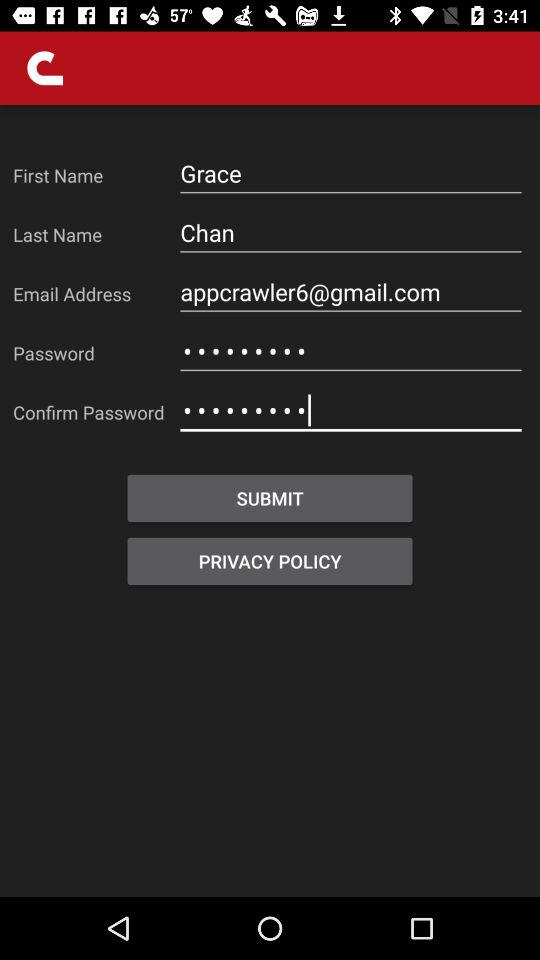What is the last name? The last name is Chan. 